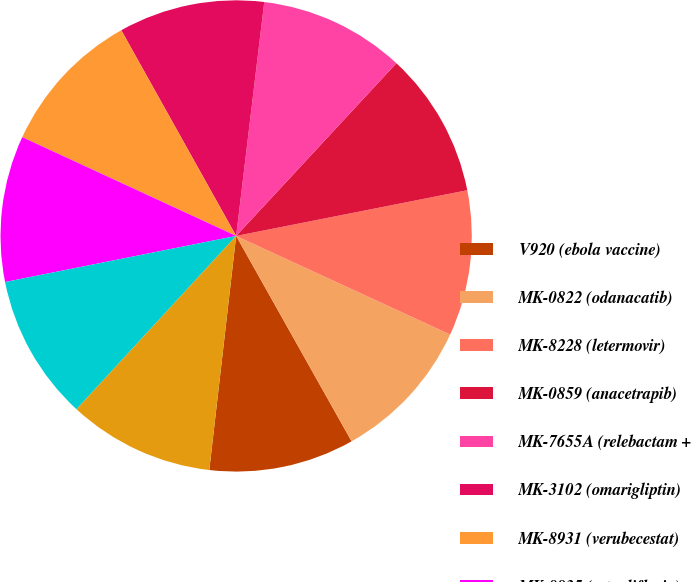Convert chart. <chart><loc_0><loc_0><loc_500><loc_500><pie_chart><fcel>V920 (ebola vaccine)<fcel>MK-0822 (odanacatib)<fcel>MK-8228 (letermovir)<fcel>MK-0859 (anacetrapib)<fcel>MK-7655A (relebactam +<fcel>MK-3102 (omarigliptin)<fcel>MK-8931 (verubecestat)<fcel>MK-8835 (ertugliflozin)<fcel>MK-8835A (ertugliflozin +<fcel>MK-8835B (ertugliflozin +<nl><fcel>9.97%<fcel>9.98%<fcel>9.98%<fcel>9.99%<fcel>10.0%<fcel>10.01%<fcel>10.01%<fcel>10.02%<fcel>10.02%<fcel>10.03%<nl></chart> 